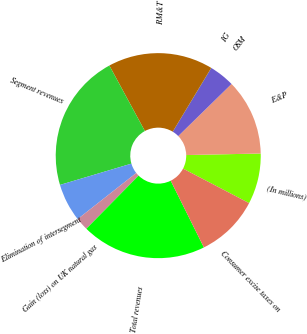Convert chart. <chart><loc_0><loc_0><loc_500><loc_500><pie_chart><fcel>(In millions)<fcel>E&P<fcel>OSM<fcel>IG<fcel>RM&T<fcel>Segment revenues<fcel>Elimination of intersegment<fcel>Gain (loss) on UK natural gas<fcel>Total revenues<fcel>Consumer excise taxes on<nl><fcel>8.0%<fcel>11.99%<fcel>4.01%<fcel>0.02%<fcel>16.56%<fcel>21.7%<fcel>6.01%<fcel>2.02%<fcel>19.71%<fcel>9.99%<nl></chart> 